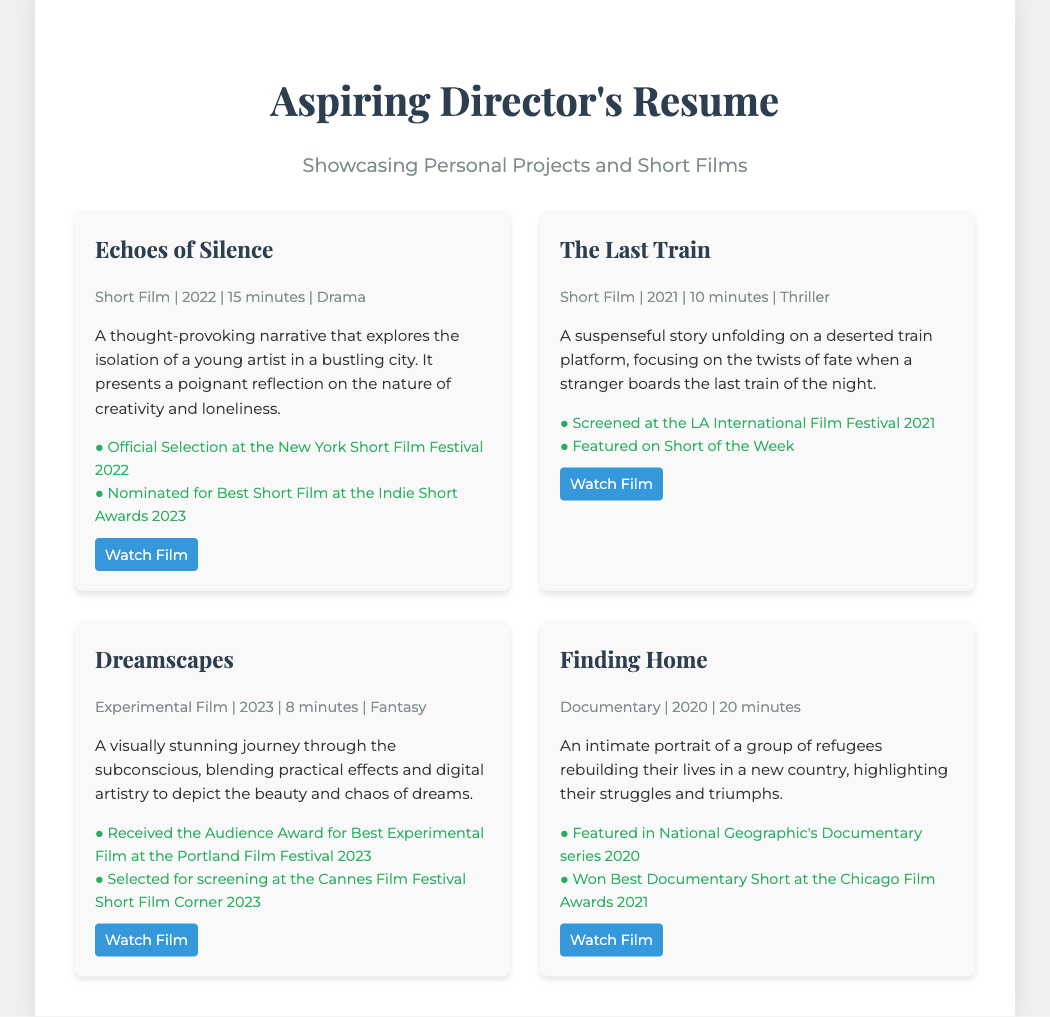What is the title of the first short film listed? The title of the first short film can be found at the top of the first project section.
Answer: Echoes of Silence In what year was "The Last Train" released? The release year for "The Last Train" is stated in the project info under its title.
Answer: 2021 How long is the duration of the film "Dreamscapes"? The duration of "Dreamscapes" is mentioned in the project info.
Answer: 8 minutes Which festival featured "Finding Home" in its documentary series? The name of the platform featuring "Finding Home" is included in the achievements section.
Answer: National Geographic Which film received the Audience Award for Best Experimental Film? The specific film that received this award is highlighted in the achievements under the "Dreamscapes" project.
Answer: Dreamscapes What genre is "The Last Train"? The genre of the film is mentioned in the project info.
Answer: Thriller Which project was nominated for Best Short Film at the Indie Short Awards 2023? The nomination for Best Short Film is specified under the achievements for "Echoes of Silence."
Answer: Echoes of Silence How many minutes is "Finding Home"? The total duration of "Finding Home" is provided in the project info.
Answer: 20 minutes Which film combines practical effects and digital artistry? The film that features this combination is described in its project description.
Answer: Dreamscapes 